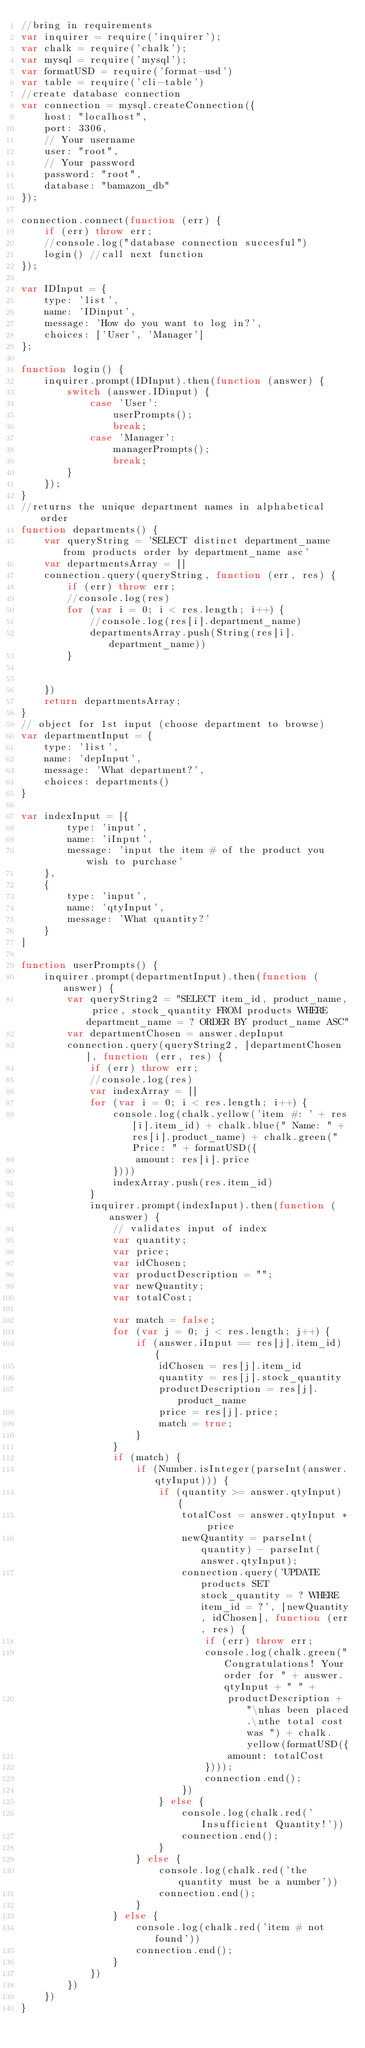<code> <loc_0><loc_0><loc_500><loc_500><_JavaScript_>//bring in requirements
var inquirer = require('inquirer');
var chalk = require('chalk');
var mysql = require('mysql');
var formatUSD = require('format-usd')
var table = require('cli-table')
//create database connection
var connection = mysql.createConnection({
    host: "localhost",
    port: 3306,
    // Your username
    user: "root",
    // Your password
    password: "root",
    database: "bamazon_db"
});

connection.connect(function (err) {
    if (err) throw err;
    //console.log("database connection succesful")
    login() //call next function
});

var IDInput = {
    type: 'list',
    name: 'IDinput',
    message: 'How do you want to log in?',
    choices: ['User', 'Manager']
};

function login() {
    inquirer.prompt(IDInput).then(function (answer) {
        switch (answer.IDinput) {
            case 'User':
                userPrompts();
                break;
            case 'Manager':
                managerPrompts();
                break;
        }
    });
}
//returns the unique department names in alphabetical order
function departments() {
    var queryString = 'SELECT distinct department_name from products order by department_name asc'
    var departmentsArray = []
    connection.query(queryString, function (err, res) {
        if (err) throw err;
        //console.log(res)
        for (var i = 0; i < res.length; i++) {
            //console.log(res[i].department_name)
            departmentsArray.push(String(res[i].department_name))
        }


    })
    return departmentsArray;
}
// object for 1st input (choose department to browse)
var departmentInput = {
    type: 'list',
    name: 'depInput',
    message: 'What department?',
    choices: departments()
}

var indexInput = [{
        type: 'input',
        name: 'iInput',
        message: 'input the item # of the product you wish to purchase'
    },
    {
        type: 'input',
        name: 'qtyInput',
        message: 'What quantity?'
    }
]

function userPrompts() {
    inquirer.prompt(departmentInput).then(function (answer) {
        var queryString2 = "SELECT item_id, product_name, price, stock_quantity FROM products WHERE department_name = ? ORDER BY product_name ASC"
        var departmentChosen = answer.depInput
        connection.query(queryString2, [departmentChosen], function (err, res) {
            if (err) throw err;
            //console.log(res)
            var indexArray = []
            for (var i = 0; i < res.length; i++) {
                console.log(chalk.yellow('item #: ' + res[i].item_id) + chalk.blue(" Name: " + res[i].product_name) + chalk.green(" Price: " + formatUSD({
                    amount: res[i].price
                })))
                indexArray.push(res.item_id)
            }
            inquirer.prompt(indexInput).then(function (answer) {
                // validates input of index
                var quantity;
                var price;
                var idChosen;
                var productDescription = "";
                var newQuantity;
                var totalCost;

                var match = false;
                for (var j = 0; j < res.length; j++) {
                    if (answer.iInput == res[j].item_id) {
                        idChosen = res[j].item_id
                        quantity = res[j].stock_quantity
                        productDescription = res[j].product_name
                        price = res[j].price;
                        match = true;
                    }
                }
                if (match) {
                    if (Number.isInteger(parseInt(answer.qtyInput))) {
                        if (quantity >= answer.qtyInput) {
                            totalCost = answer.qtyInput * price
                            newQuantity = parseInt(quantity) - parseInt(answer.qtyInput);
                            connection.query('UPDATE products SET stock_quantity = ? WHERE item_id = ?', [newQuantity, idChosen], function (err, res) {
                                if (err) throw err;
                                console.log(chalk.green("Congratulations! Your order for " + answer.qtyInput + " " +
                                    productDescription + "\nhas been placed.\nthe total cost was ") + chalk.yellow(formatUSD({
                                    amount: totalCost
                                })));
                                connection.end();
                            })
                        } else {
                            console.log(chalk.red('Insufficient Quantity!'))
                            connection.end();
                        }
                    } else {
                        console.log(chalk.red('the quantity must be a number'))
                        connection.end();
                    }
                } else {
                    console.log(chalk.red('item # not found'))
                    connection.end();
                }
            })
        })
    })
}
</code> 